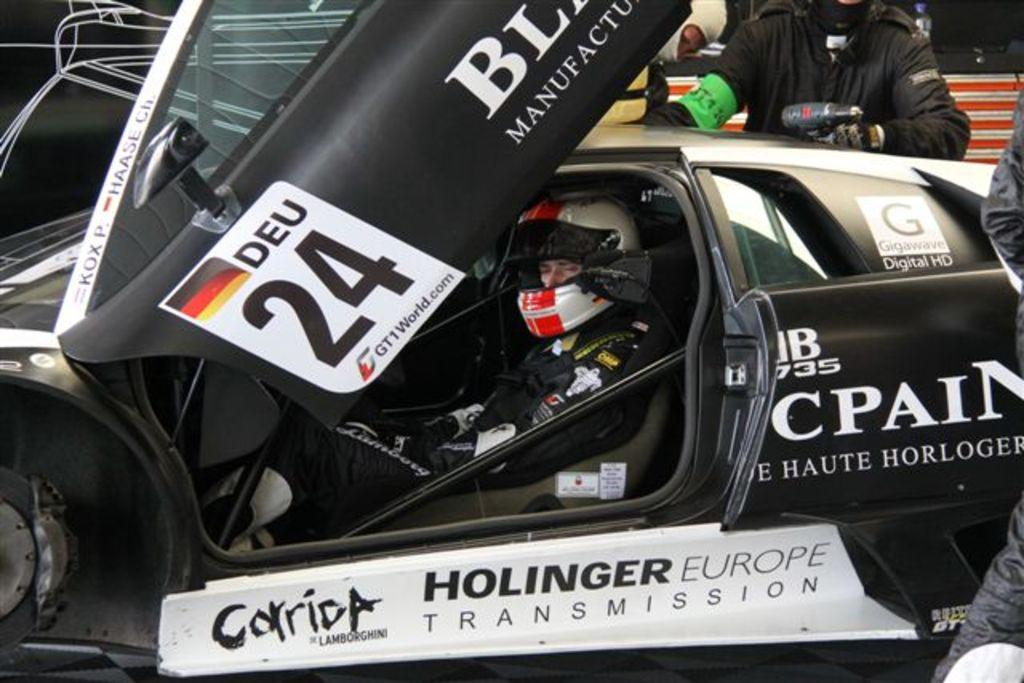What is the person in the image doing? The person is sitting inside a vehicle in the image. What is the person wearing? The person is wearing a dress and helmet. Are there any other people visible in the image? Yes, there are more people visible to the right of the vehicle. What is one of the people holding? One person is holding a machine. What type of oatmeal is being prepared by the person holding the machine? There is no oatmeal present in the image, and the person holding the machine is not preparing any food. 